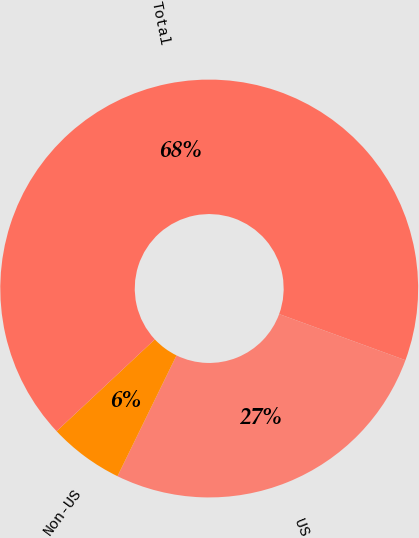Convert chart to OTSL. <chart><loc_0><loc_0><loc_500><loc_500><pie_chart><fcel>US<fcel>Non-US<fcel>Total<nl><fcel>26.66%<fcel>5.8%<fcel>67.54%<nl></chart> 